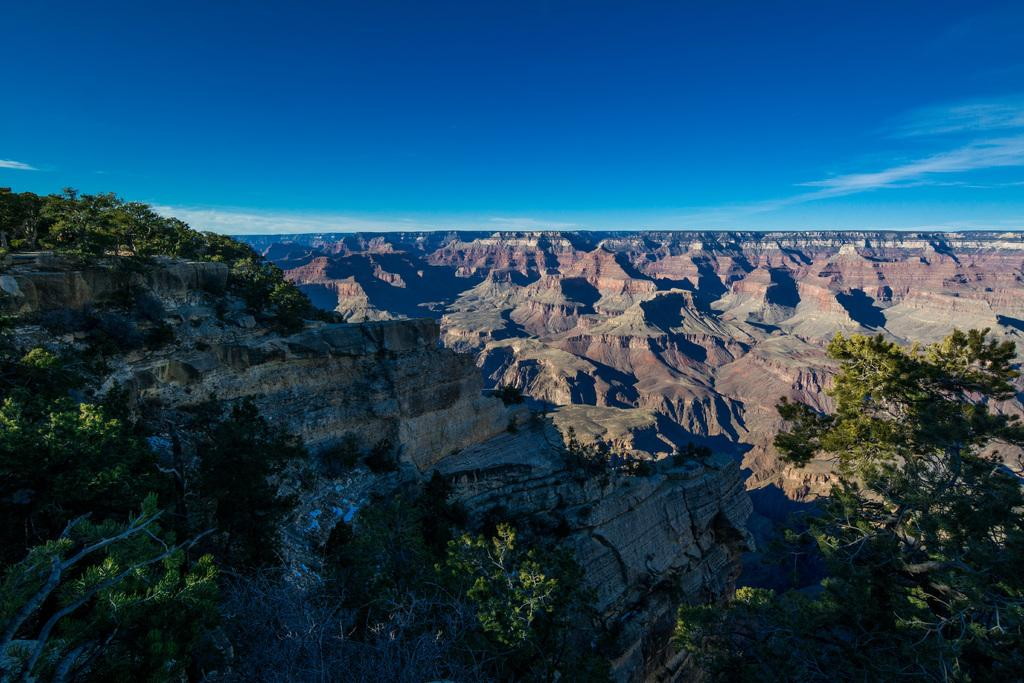What type of view is provided in the image? The image is an aerial view. What natural features can be seen from this perspective? There are mountains and trees visible in the image. What is visible in the sky at the top of the image? Clouds are present in the sky at the top of the image. What type of beef is being served on the bridge in the image? There is no beef or bridge present in the image; it is an aerial view of mountains and trees. Can you tell me the name of the brother who built the structure in the image? There is no structure or person mentioned in the image. 